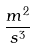<formula> <loc_0><loc_0><loc_500><loc_500>\frac { m ^ { 2 } } { s ^ { 3 } }</formula> 